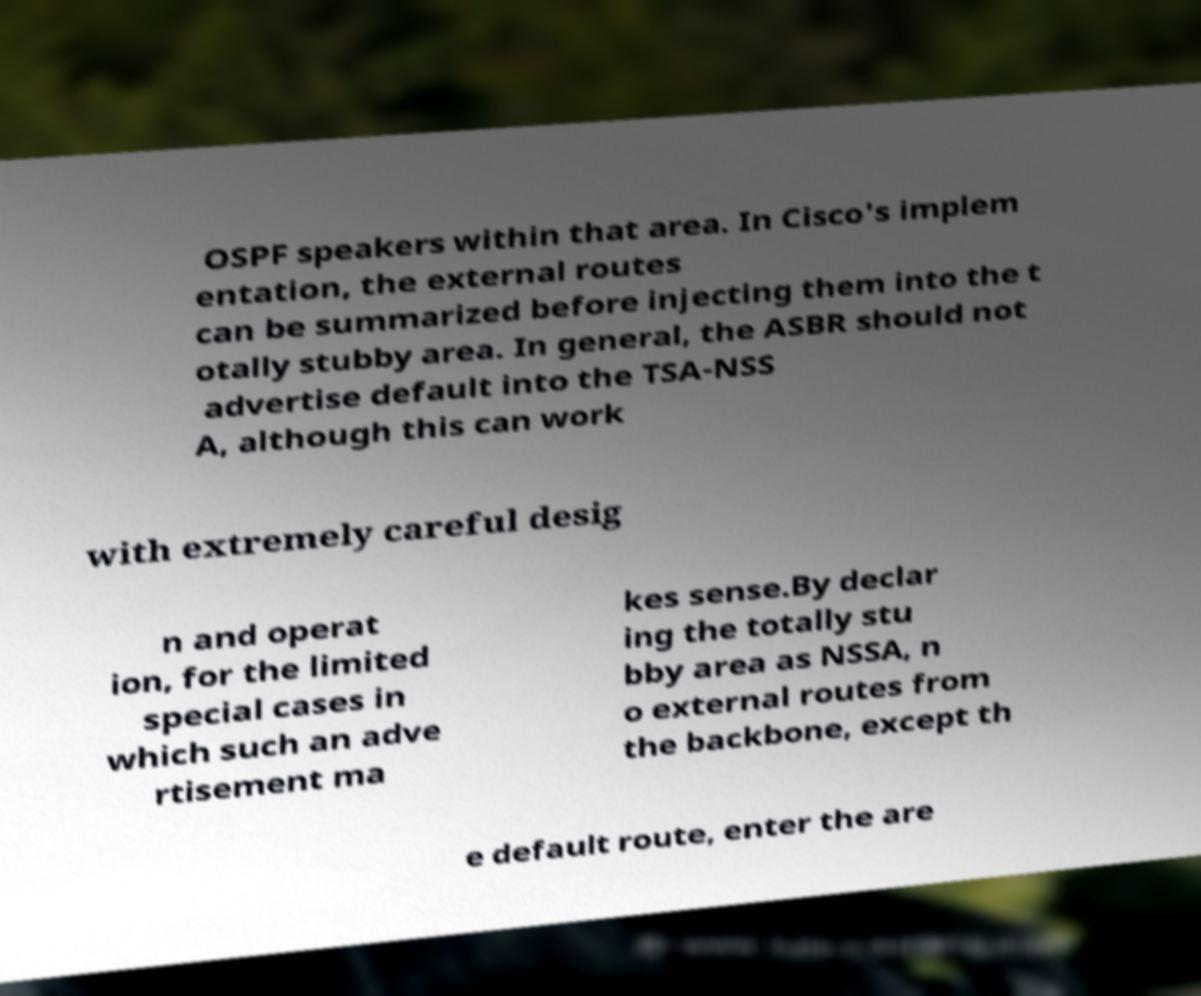Could you extract and type out the text from this image? OSPF speakers within that area. In Cisco's implem entation, the external routes can be summarized before injecting them into the t otally stubby area. In general, the ASBR should not advertise default into the TSA-NSS A, although this can work with extremely careful desig n and operat ion, for the limited special cases in which such an adve rtisement ma kes sense.By declar ing the totally stu bby area as NSSA, n o external routes from the backbone, except th e default route, enter the are 